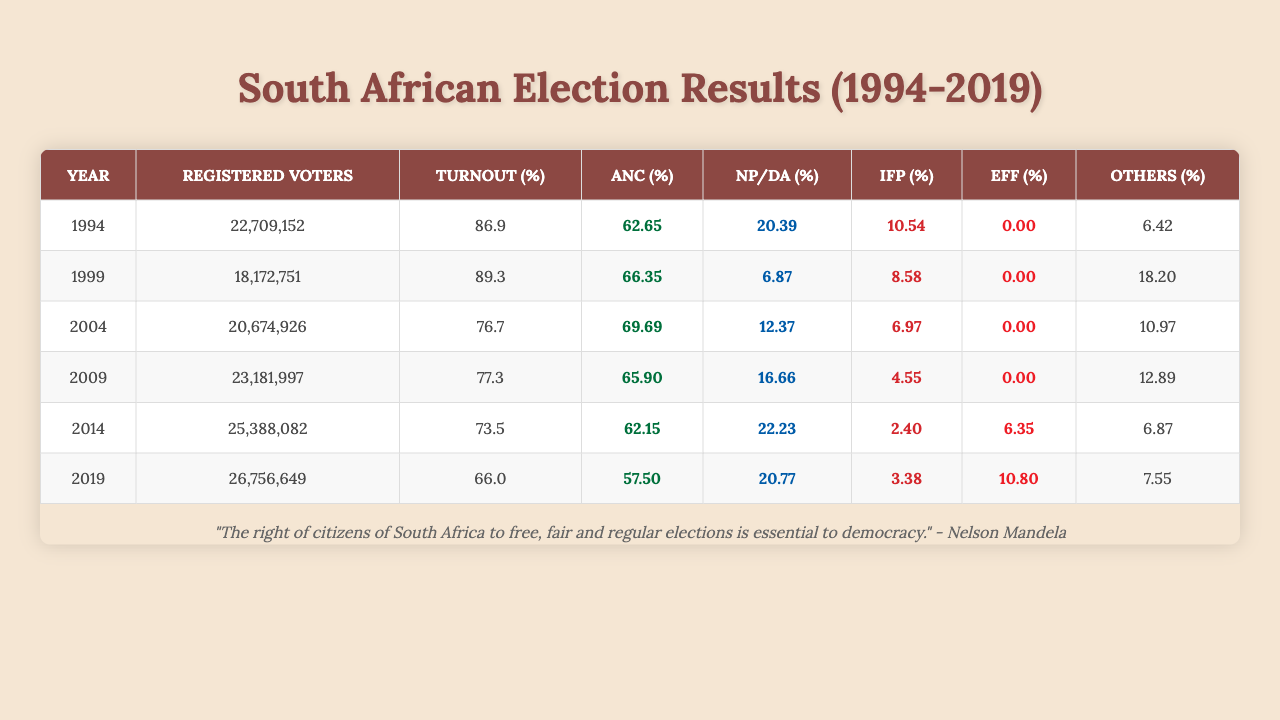What was the voter turnout percentage in the 1994 elections? The table indicates that the voter turnout percentage for the year 1994 is 86.9%.
Answer: 86.9% Which party had the highest vote share in the 2014 elections? According to the data, the ANC had the highest vote share in 2014, which was 62.15%.
Answer: ANC What is the average voter turnout percentage from 1994 to 2019? The voter turnout percentages are 86.9, 89.3, 76.73, 77.3, 73.48, and 66.05. Summing these gives 469.73, which divided by 6 results in an average of about 78.29%.
Answer: 78.29% Did the NP party receive more than 10% of the vote share in any of the elections from 1994 to 2019? The table shows that the NP party's highest vote share was 20.39% in 1994, so it did exceed 10% during that election.
Answer: Yes What was the difference in the ANC vote share between 1994 and 2019? The ANC vote share in 1994 was 62.65%, and in 2019 it was 57.50%. The difference is 62.65 - 57.50 = 5.15%.
Answer: 5.15% How many total registered voters were there in the elections held in 2004 and 2009 combined? The total registered voters for 2004 was 20,674,926 and for 2009 was 23,181,997. Adding these gives 20,674,926 + 23,181,997 = 43,856,923.
Answer: 43,856,923 What was the vote share of the IFPO party in 2009? The IFPO party's vote share in 2009 was 4.55%, as shown in the table.
Answer: 4.55% Which election year had the lowest voter turnout? Looking at the percentages provided, 2019 had the lowest voter turnout percentage at 66.05%.
Answer: 2019 How many parties received a vote share of less than 2% in the 1994 elections? The table shows that only the PAC (1.25%), ACDP (0.45%), and other smaller parties received less than 2% in 1994, totaling 3 parties.
Answer: 3 What was the vote share for the DA party in 2019 and how does it compare to its vote share in 2014? The DA vote share in 2019 was 20.77%, while in 2014 it was 22.23%. The difference is 22.23 - 20.77 = 1.46%, showing a decline.
Answer: 20.77%; decline of 1.46% 